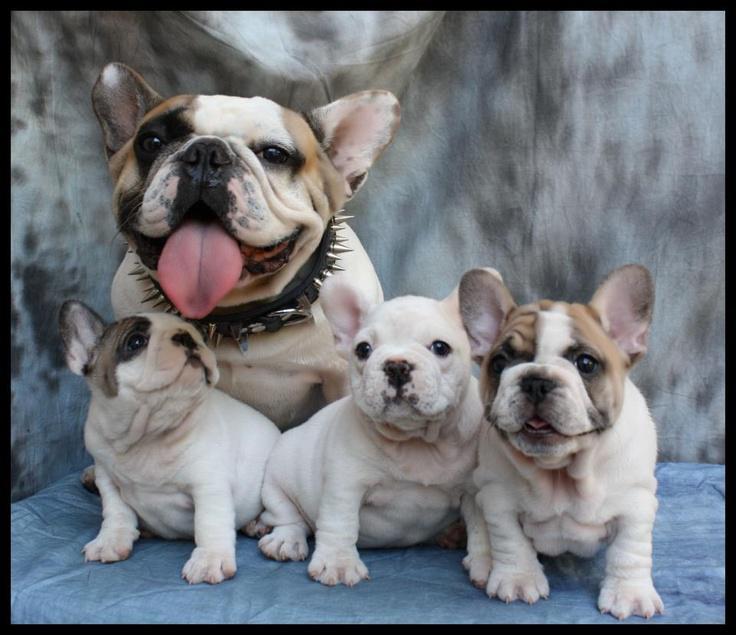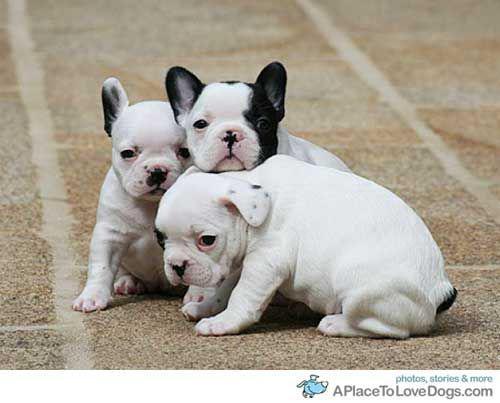The first image is the image on the left, the second image is the image on the right. For the images displayed, is the sentence "An image shows at least three dogs, including a black one, all posed together on a fabric covered seat." factually correct? Answer yes or no. No. The first image is the image on the left, the second image is the image on the right. Evaluate the accuracy of this statement regarding the images: "There is no more than three dogs in the right image.". Is it true? Answer yes or no. Yes. 